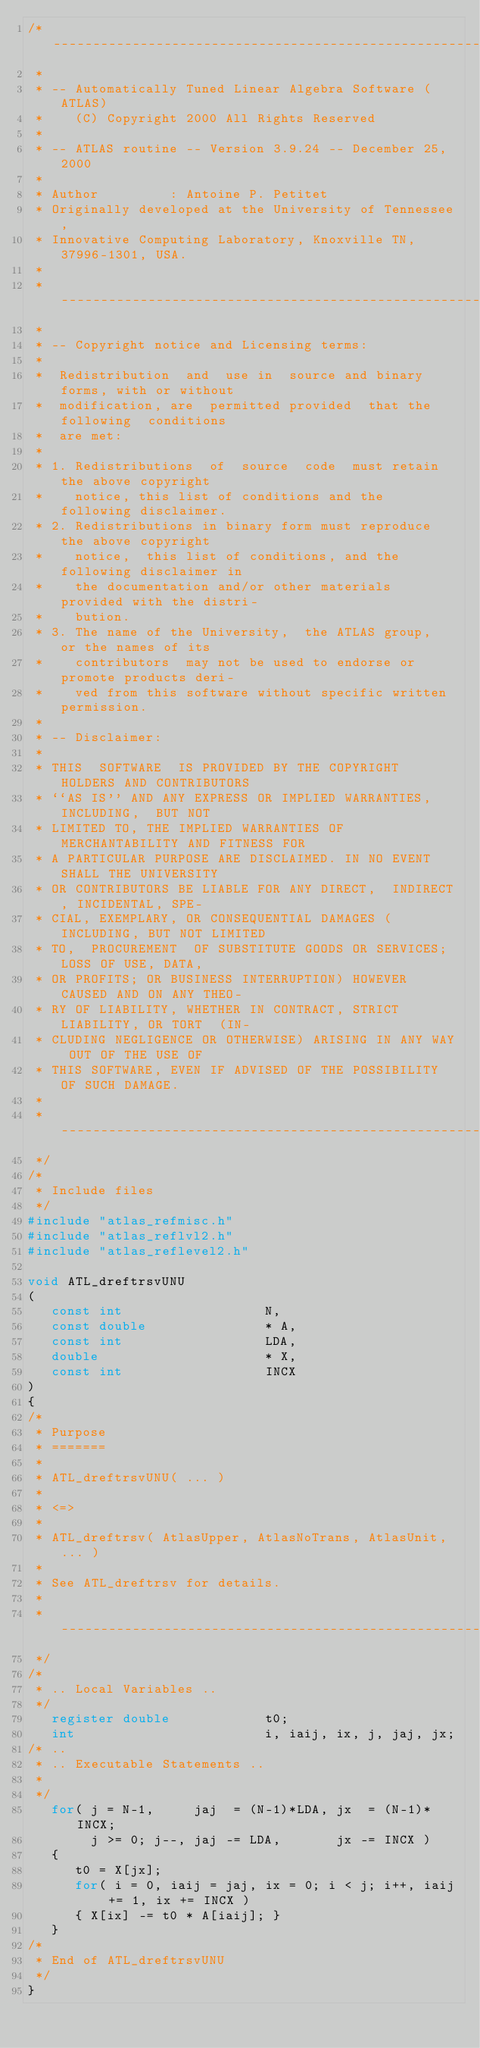Convert code to text. <code><loc_0><loc_0><loc_500><loc_500><_C_>/* ---------------------------------------------------------------------
 *
 * -- Automatically Tuned Linear Algebra Software (ATLAS)
 *    (C) Copyright 2000 All Rights Reserved
 *
 * -- ATLAS routine -- Version 3.9.24 -- December 25, 2000
 *
 * Author         : Antoine P. Petitet
 * Originally developed at the University of Tennessee,
 * Innovative Computing Laboratory, Knoxville TN, 37996-1301, USA.
 *
 * ---------------------------------------------------------------------
 *
 * -- Copyright notice and Licensing terms:
 *
 *  Redistribution  and  use in  source and binary forms, with or without
 *  modification, are  permitted provided  that the following  conditions
 *  are met:
 *
 * 1. Redistributions  of  source  code  must retain the above copyright
 *    notice, this list of conditions and the following disclaimer.
 * 2. Redistributions in binary form must reproduce  the above copyright
 *    notice,  this list of conditions, and the  following disclaimer in
 *    the documentation and/or other materials provided with the distri-
 *    bution.
 * 3. The name of the University,  the ATLAS group,  or the names of its
 *    contributors  may not be used to endorse or promote products deri-
 *    ved from this software without specific written permission.
 *
 * -- Disclaimer:
 *
 * THIS  SOFTWARE  IS PROVIDED BY THE COPYRIGHT HOLDERS AND CONTRIBUTORS
 * ``AS IS'' AND ANY EXPRESS OR IMPLIED WARRANTIES,  INCLUDING,  BUT NOT
 * LIMITED TO, THE IMPLIED WARRANTIES OF MERCHANTABILITY AND FITNESS FOR
 * A PARTICULAR PURPOSE ARE DISCLAIMED. IN NO EVENT SHALL THE UNIVERSITY
 * OR CONTRIBUTORS BE LIABLE FOR ANY DIRECT,  INDIRECT, INCIDENTAL, SPE-
 * CIAL, EXEMPLARY, OR CONSEQUENTIAL DAMAGES (INCLUDING, BUT NOT LIMITED
 * TO,  PROCUREMENT  OF SUBSTITUTE GOODS OR SERVICES; LOSS OF USE, DATA,
 * OR PROFITS; OR BUSINESS INTERRUPTION) HOWEVER CAUSED AND ON ANY THEO-
 * RY OF LIABILITY, WHETHER IN CONTRACT, STRICT LIABILITY, OR TORT  (IN-
 * CLUDING NEGLIGENCE OR OTHERWISE) ARISING IN ANY WAY OUT OF THE USE OF
 * THIS SOFTWARE, EVEN IF ADVISED OF THE POSSIBILITY OF SUCH DAMAGE.
 *
 * ---------------------------------------------------------------------
 */
/*
 * Include files
 */
#include "atlas_refmisc.h"
#include "atlas_reflvl2.h"
#include "atlas_reflevel2.h"

void ATL_dreftrsvUNU
(
   const int                  N,
   const double               * A,
   const int                  LDA,
   double                     * X,
   const int                  INCX
)
{
/*
 * Purpose
 * =======
 *
 * ATL_dreftrsvUNU( ... )
 *
 * <=>
 *
 * ATL_dreftrsv( AtlasUpper, AtlasNoTrans, AtlasUnit, ... )
 *
 * See ATL_dreftrsv for details.
 *
 * ---------------------------------------------------------------------
 */
/*
 * .. Local Variables ..
 */
   register double            t0;
   int                        i, iaij, ix, j, jaj, jx;
/* ..
 * .. Executable Statements ..
 *
 */
   for( j = N-1,     jaj  = (N-1)*LDA, jx  = (N-1)*INCX;
        j >= 0; j--, jaj -= LDA,       jx -= INCX )
   {
      t0 = X[jx];
      for( i = 0, iaij = jaj, ix = 0; i < j; i++, iaij += 1, ix += INCX )
      { X[ix] -= t0 * A[iaij]; }
   }
/*
 * End of ATL_dreftrsvUNU
 */
}
</code> 